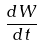<formula> <loc_0><loc_0><loc_500><loc_500>\frac { d W } { d t }</formula> 